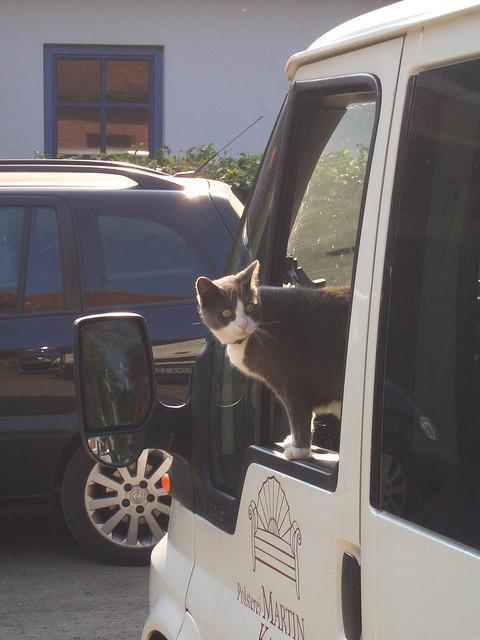How many vehicles are there?
Give a very brief answer. 2. How many wheels does the van have?
Give a very brief answer. 4. How many cars are there?
Give a very brief answer. 2. 